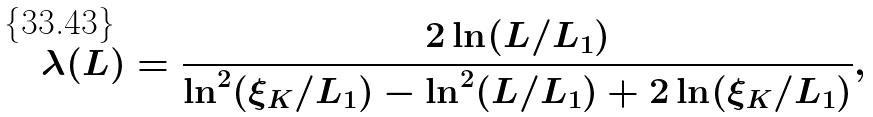Convert formula to latex. <formula><loc_0><loc_0><loc_500><loc_500>\lambda ( L ) = \frac { 2 \ln ( L / L _ { 1 } ) } { \ln ^ { 2 } ( \xi _ { K } / L _ { 1 } ) - \ln ^ { 2 } ( L / L _ { 1 } ) + 2 \ln ( \xi _ { K } / L _ { 1 } ) } ,</formula> 